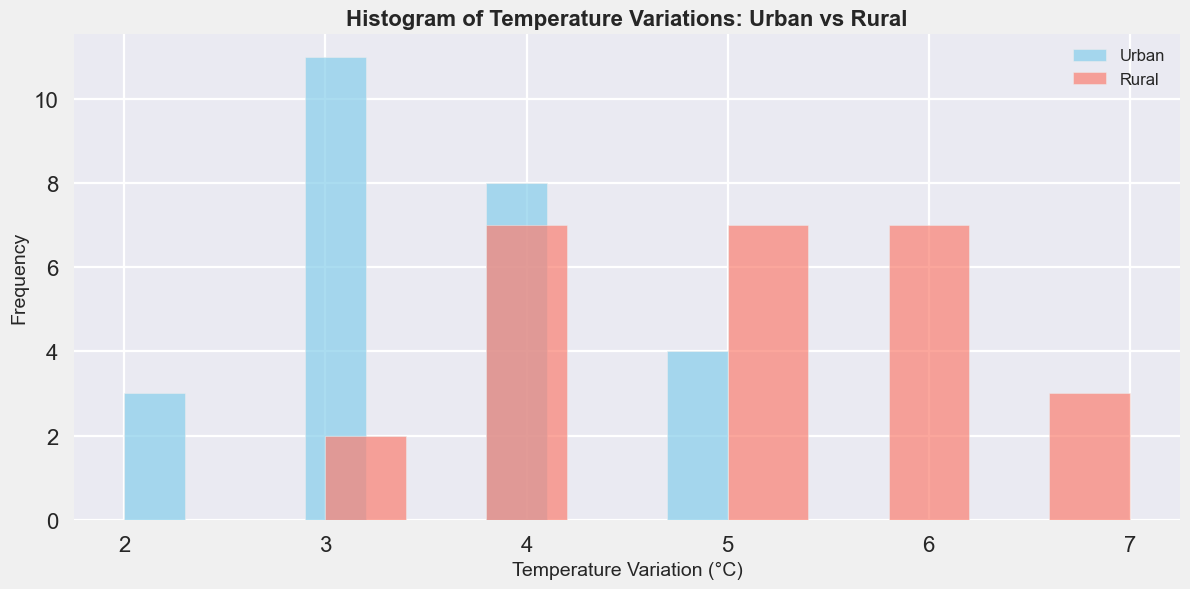What are the most common temperature variations for urban areas? The histogram shows the frequency (height of the bars) of temperature variations for urban areas. The tallest bars represent the most common variations. In the urban temperature variation histogram, the bars for 3°C and 4°C are the tallest, indicating these are the most frequent variations.
Answer: 3°C and 4°C Which type (urban or rural) has a higher variation frequency around 5°C? Compare the heights of the bars corresponding to 5°C for both urban and rural histograms. The bar for rural areas at 5°C is taller than the corresponding bar for urban areas, indicating a higher frequency in rural areas.
Answer: Rural What is the approximate total frequency of temperature variations in urban areas at 2°C and 3°C combined? Find the heights of the bars corresponding to 2°C and 3°C in the urban histogram and sum them up. The frequencies are approximately 3 (2°C) and 6 (3°C), summing to around 9.
Answer: 9 Are there any temperature variations that are exclusive to either urban or rural areas? Look for bars present in one histogram but absent in the other. All temperature variations (from 2°C to 7°C) are present in both urban and rural histograms, meaning no variation is exclusive.
Answer: No Which temperature variation shows the largest difference in frequency between urban and rural areas? Calculate the difference in the height of bars for each temperature variation between urban and rural histograms. The bar at 3°C shows a frequency difference, with urban areas having a higher frequency at this variation compared to rural areas.
Answer: 3°C What temperature variation has the lowest frequency in rural areas? Look for the shortest bar in the rural histogram. The shortest bar is at 3°C, indicating the lowest frequency for rural temperature variation.
Answer: 3°C Compare the highest frequency of temperature variation for both urban and rural areas. Identify the highest bars in both histograms. The highest bar in urban areas is at 3°C while the highest in rural areas is at 5°C.
Answer: Urban: 3°C, Rural: 5°C What percentage of urban temperature variations occur at 3°C or 4°C? Calculate the frequencies of 3°C and 4°C variations in urban areas and divide by the total number of urban entries, then multiply by 100. Frequency at 3°C is 6, and 4°C is 5, totaling 11. The total urban entries are 27. Percentage = (11/27)*100 ≈ 40.74%.
Answer: 40.74% 